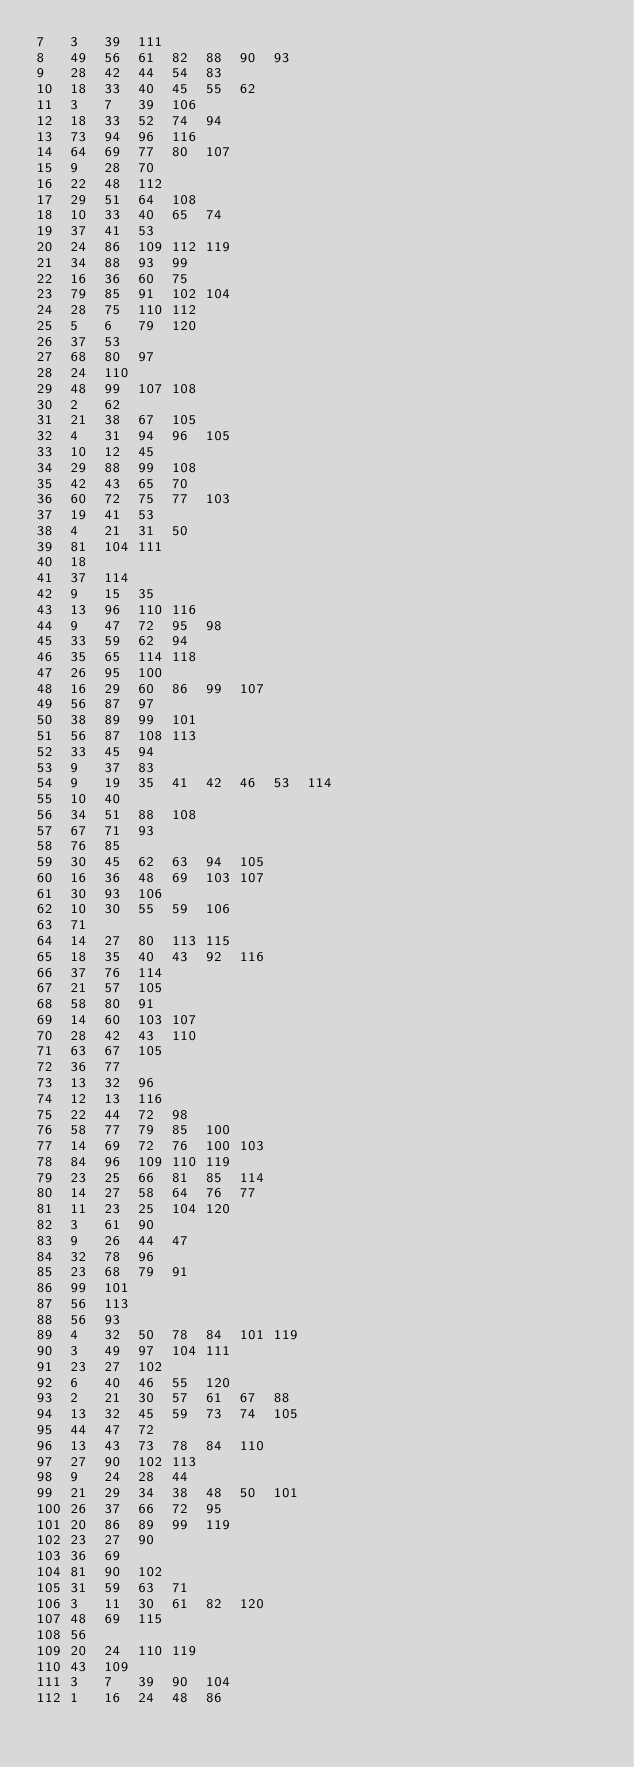Convert code to text. <code><loc_0><loc_0><loc_500><loc_500><_Perl_>7	3	39	111
8	49	56	61	82	88	90	93
9	28	42	44	54	83
10	18	33	40	45	55	62
11	3	7	39	106
12	18	33	52	74	94
13	73	94	96	116
14	64	69	77	80	107
15	9	28	70
16	22	48	112
17	29	51	64	108
18	10	33	40	65	74
19	37	41	53
20	24	86	109	112	119
21	34	88	93	99
22	16	36	60	75
23	79	85	91	102	104
24	28	75	110	112
25	5	6	79	120
26	37	53
27	68	80	97
28	24	110
29	48	99	107	108
30	2	62
31	21	38	67	105
32	4	31	94	96	105
33	10	12	45
34	29	88	99	108
35	42	43	65	70
36	60	72	75	77	103
37	19	41	53
38	4	21	31	50
39	81	104	111
40	18
41	37	114
42	9	15	35
43	13	96	110	116
44	9	47	72	95	98
45	33	59	62	94
46	35	65	114	118
47	26	95	100
48	16	29	60	86	99	107
49	56	87	97
50	38	89	99	101
51	56	87	108	113
52	33	45	94
53	9	37	83
54	9	19	35	41	42	46	53	114
55	10	40
56	34	51	88	108
57	67	71	93
58	76	85
59	30	45	62	63	94	105
60	16	36	48	69	103	107
61	30	93	106
62	10	30	55	59	106
63	71
64	14	27	80	113	115
65	18	35	40	43	92	116
66	37	76	114
67	21	57	105
68	58	80	91
69	14	60	103	107
70	28	42	43	110
71	63	67	105
72	36	77
73	13	32	96
74	12	13	116
75	22	44	72	98
76	58	77	79	85	100
77	14	69	72	76	100	103
78	84	96	109	110	119
79	23	25	66	81	85	114
80	14	27	58	64	76	77
81	11	23	25	104	120
82	3	61	90
83	9	26	44	47
84	32	78	96
85	23	68	79	91
86	99	101
87	56	113
88	56	93
89	4	32	50	78	84	101	119
90	3	49	97	104	111
91	23	27	102
92	6	40	46	55	120
93	2	21	30	57	61	67	88
94	13	32	45	59	73	74	105
95	44	47	72
96	13	43	73	78	84	110
97	27	90	102	113
98	9	24	28	44
99	21	29	34	38	48	50	101
100	26	37	66	72	95
101	20	86	89	99	119
102	23	27	90
103	36	69
104	81	90	102
105	31	59	63	71
106	3	11	30	61	82	120
107	48	69	115
108	56
109	20	24	110	119
110	43	109
111	3	7	39	90	104
112	1	16	24	48	86</code> 